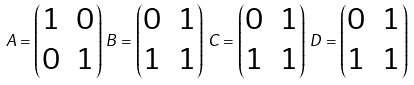<formula> <loc_0><loc_0><loc_500><loc_500>A = \begin{pmatrix} 1 & 0 \\ 0 & 1 \end{pmatrix} \, B = \begin{pmatrix} 0 & 1 \\ 1 & 1 \end{pmatrix} \, C = \begin{pmatrix} 0 & 1 \\ 1 & 1 \end{pmatrix} \, D = \begin{pmatrix} 0 & 1 \\ 1 & 1 \end{pmatrix} \,</formula> 